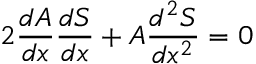<formula> <loc_0><loc_0><loc_500><loc_500>2 \frac { d A } { d x } \frac { d S } { d x } + A \frac { d ^ { 2 } S } { d x ^ { 2 } } = 0</formula> 